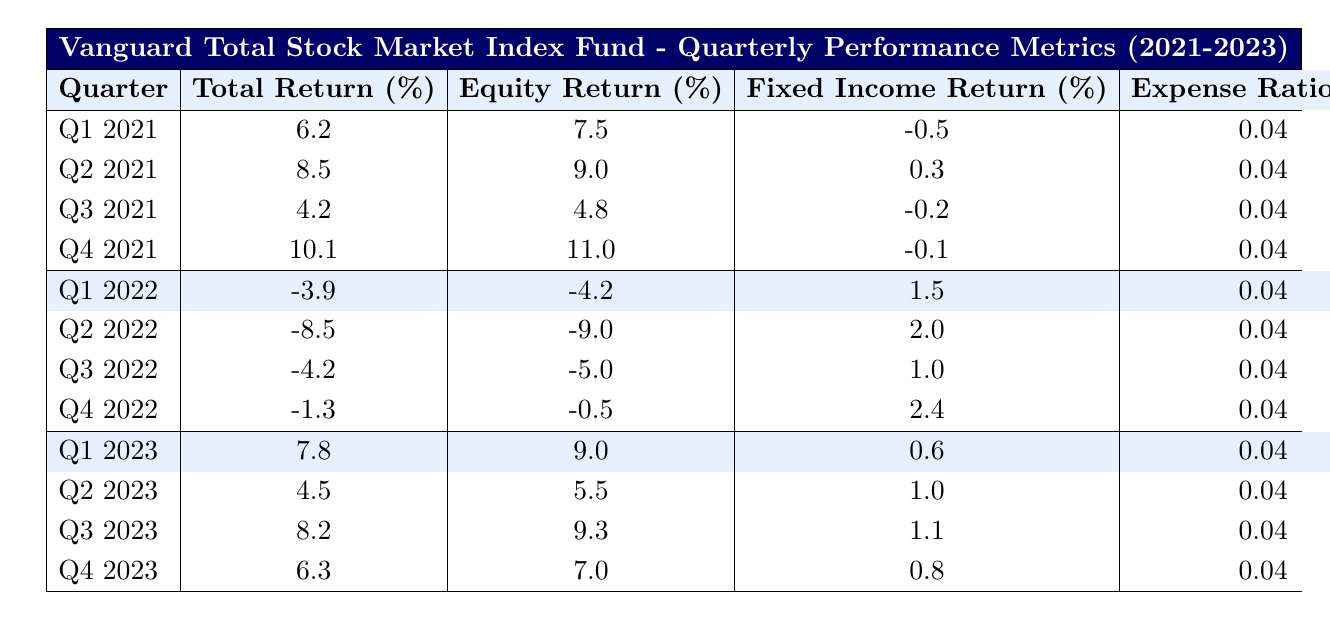What was the total return in Q4 2022? The table lists the total return for Q4 2022 as -1.3%.
Answer: -1.3% Which quarter had the highest equity return? Looking through the equity returns, the highest value is 11.0% recorded in Q4 2021.
Answer: Q4 2021 What is the average total return over all four quarters of 2021? The total returns for 2021 are 6.2, 8.5, 4.2, and 10.1. Their sum is 6.2 + 8.5 + 4.2 + 10.1 = 29.0. Dividing by 4 gives an average total return of 29.0/4 = 7.25%.
Answer: 7.25% Did the fund ever have a positive fixed income return in 2022? Reviewing the fixed income returns for 2022, they are 1.5%, 2.0%, and 2.4% for Q1, Q2, and Q4 respectively, while Q3 is the only quarter with a negative return of 1.0%. So yes, there were positive returns in three out of four quarters in 2022.
Answer: Yes What is the trend of total returns from Q1 2021 to Q4 2023? Analyzing the total returns over these quarters: positive returns in Q1-Q4 2021, negative returns in Q1-Q4 2022, and positive returns in Q1-Q4 2023, indicating a shift from gains to losses in 2022 and a recovery in 2023.
Answer: Fluctuating; gains in '21, losses in '22, gains in '23 What is the fund's size when the total return is highest? The highest total return reported is 10.1% in Q4 2021, where the fund size is listed as $165 billion.
Answer: $165 billion Which quarter had the lowest number of holdings, and how many were there? By checking the number of holdings for each quarter, Q1 2021 had the lowest number of holdings at 3675.
Answer: 3675 How do the equity returns in 2023 compare to those in 2021? In 2021, the equity returns for Q1, Q2, Q3, and Q4 were 7.5%, 9.0%, 4.8%, and 11.0%. In 2023, Q1, Q2, Q3, and Q4 had equity returns of 9.0%, 5.5%, 9.3%, and 7.0%. Overall, returns were higher for Q1 and Q3 in 2023 but lower for Q2 and Q4.
Answer: Mixed comparison; Q1 & Q3 higher, Q2 & Q4 lower What percentage of the fund's total returns were negative in 2022? In 2022, the total returns were negative for all four quarters: -3.9, -8.5, -4.2, and -1.3, making 4 out of 4 quarters negative, which is 100%.
Answer: 100% 